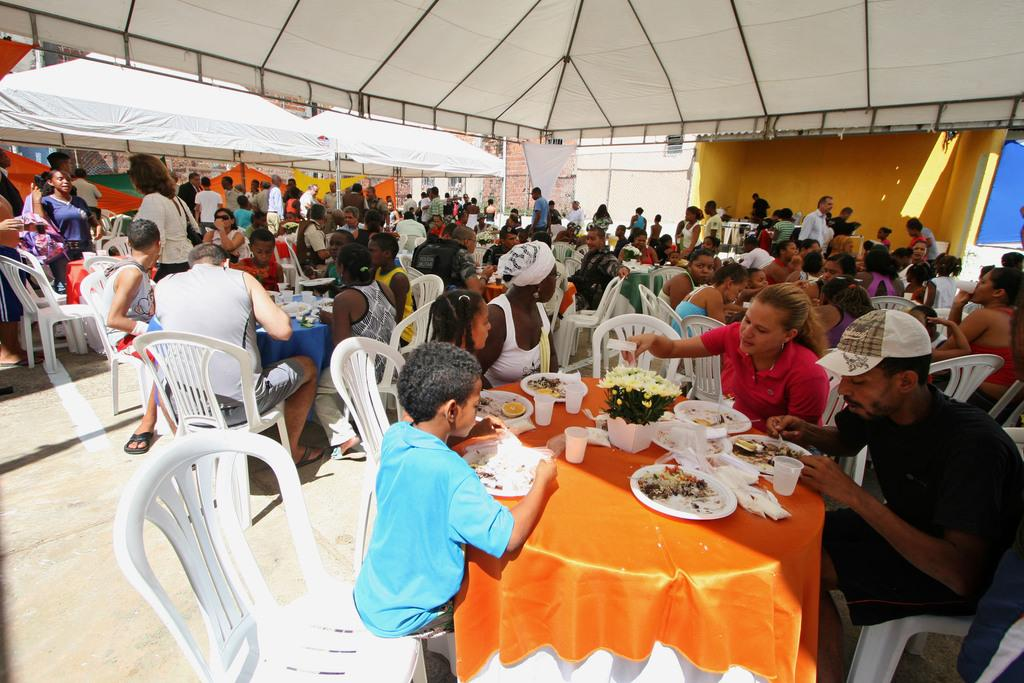What are the people in the image doing? People are sitting on chairs around tables in the image. What objects can be seen on the tables? There are plates, glasses, and flower pots on the tables. What structures are visible at the top of the image? There are tents visible at the top of the image. What type of mass is being performed in the image? There is no mass being performed in the image; people are sitting around tables. How does the love between the people in the image manifest itself? The image does not show any indication of love between the people; it only shows people sitting around tables. 